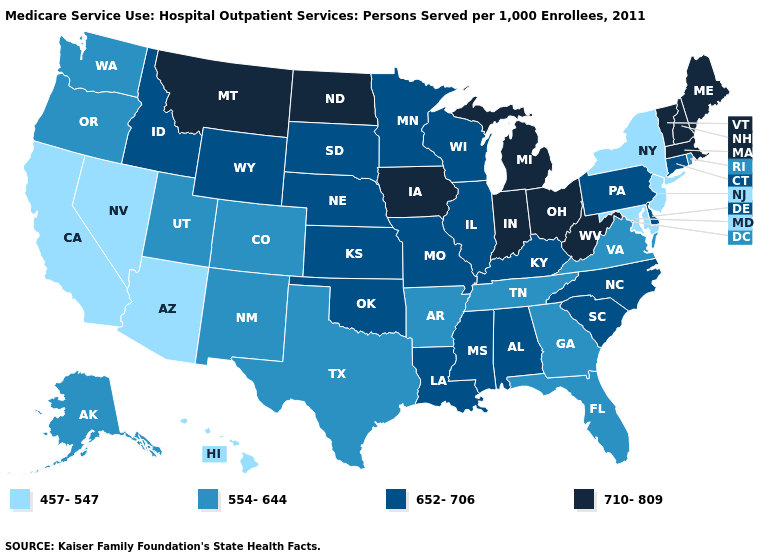What is the value of Georgia?
Keep it brief. 554-644. Does the first symbol in the legend represent the smallest category?
Write a very short answer. Yes. Does Washington have a higher value than Kentucky?
Write a very short answer. No. Among the states that border Indiana , does Michigan have the lowest value?
Quick response, please. No. What is the value of New York?
Answer briefly. 457-547. Name the states that have a value in the range 554-644?
Quick response, please. Alaska, Arkansas, Colorado, Florida, Georgia, New Mexico, Oregon, Rhode Island, Tennessee, Texas, Utah, Virginia, Washington. Name the states that have a value in the range 710-809?
Give a very brief answer. Indiana, Iowa, Maine, Massachusetts, Michigan, Montana, New Hampshire, North Dakota, Ohio, Vermont, West Virginia. What is the lowest value in the USA?
Keep it brief. 457-547. Which states have the lowest value in the Northeast?
Concise answer only. New Jersey, New York. Name the states that have a value in the range 652-706?
Answer briefly. Alabama, Connecticut, Delaware, Idaho, Illinois, Kansas, Kentucky, Louisiana, Minnesota, Mississippi, Missouri, Nebraska, North Carolina, Oklahoma, Pennsylvania, South Carolina, South Dakota, Wisconsin, Wyoming. Does North Dakota have the lowest value in the MidWest?
Be succinct. No. Name the states that have a value in the range 554-644?
Quick response, please. Alaska, Arkansas, Colorado, Florida, Georgia, New Mexico, Oregon, Rhode Island, Tennessee, Texas, Utah, Virginia, Washington. What is the value of Wyoming?
Give a very brief answer. 652-706. Does West Virginia have the lowest value in the USA?
Quick response, please. No. Among the states that border New Jersey , which have the lowest value?
Be succinct. New York. 